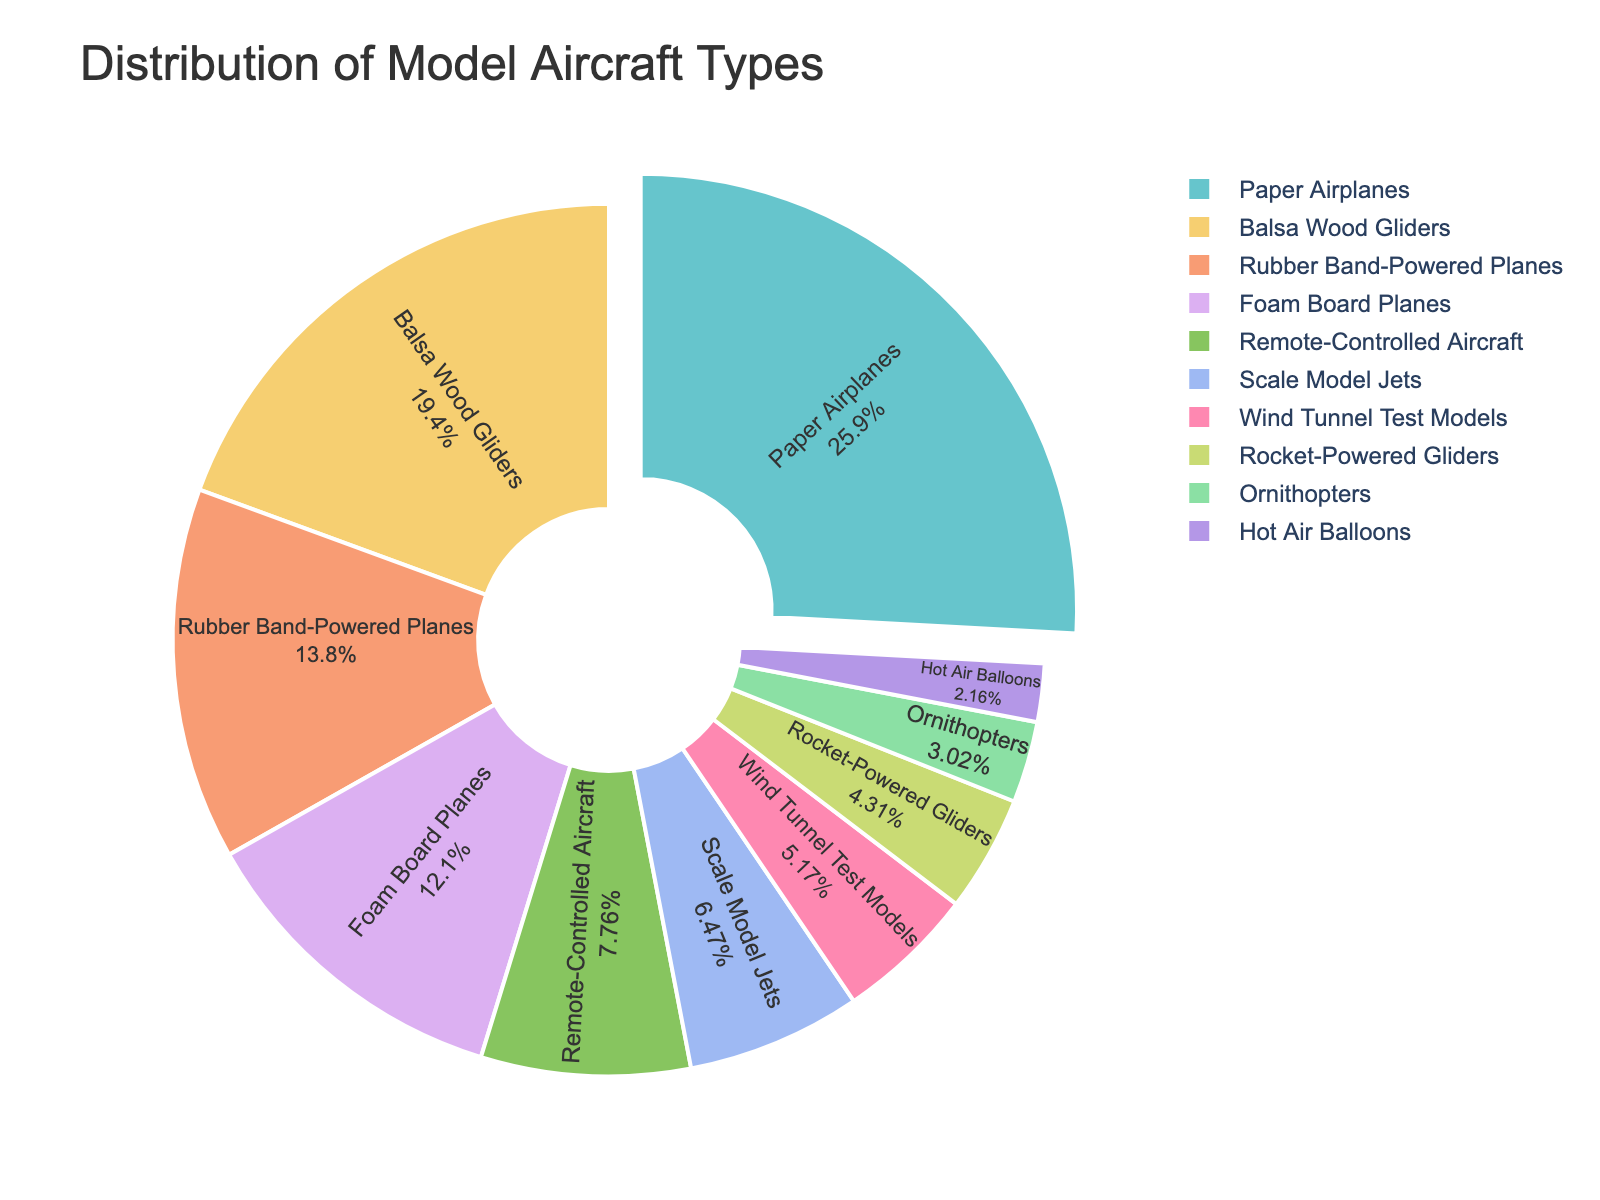Which type of model aircraft was built the most? To find the type of model aircraft built the most, we look at the segment with the largest percentage in the pie chart. Paper Airplanes have the most significant segment pulled out in the chart, indicating they are the most built type.
Answer: Paper Airplanes What percentage of the total is made up by Scale Model Jets and Hot Air Balloons combined? To find the combined percentage of Scale Model Jets and Hot Air Balloons, we add the individual percentages of these two types from the pie chart.
Answer: 10% Which type of model aircraft was built the least? To determine which type was built the least, we look at the smallest segment in the pie chart. Hot Air Balloons have the smallest segment.
Answer: Hot Air Balloons How many more Paper Airplanes were built compared to Ornithopters? To find how many more Paper Airplanes were built compared to Ornithopters, subtract the number of Ornithopters (7) from the number of Paper Airplanes (60).
Answer: 53 Are Rubber Band-Powered Planes built more frequently than Remote-Controlled Aircraft? To compare the frequency of Rubber Band-Powered Planes and Remote-Controlled Aircraft, we look at the sizes of their respective segments. Rubber Band-Powered Planes have a larger segment.
Answer: Yes What is the combined number of Wind Tunnel Test Models and Rocket-Powered Gliders? To find the combined number of Wind Tunnel Test Models and Rocket-Powered Gliders, add their numbers (12 + 10).
Answer: 22 Which three types of model aircraft make up the largest percentage of the total? To find the three types that make up the largest percentages, we look for the three largest segments. The largest segments correspond to Paper Airplanes, Balsa Wood Gliders, and Rubber Band-Powered Planes.
Answer: Paper Airplanes, Balsa Wood Gliders, and Rubber Band-Powered Planes How does the number of Foam Board Planes compare to the number of Balsa Wood Gliders? To compare the number of Foam Board Planes to Balsa Wood Gliders, we compare their respective segment sizes. Foam Board Planes (28) are fewer than Balsa Wood Gliders (45).
Answer: Fewer 